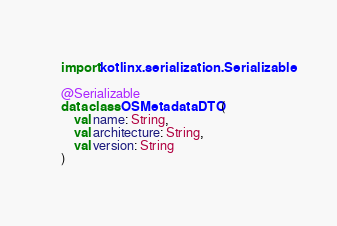<code> <loc_0><loc_0><loc_500><loc_500><_Kotlin_>import kotlinx.serialization.Serializable

@Serializable
data class OSMetadataDTO(
    val name: String,
    val architecture: String,
    val version: String
)
</code> 